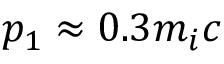Convert formula to latex. <formula><loc_0><loc_0><loc_500><loc_500>p _ { 1 } \approx 0 . 3 m _ { i } c</formula> 